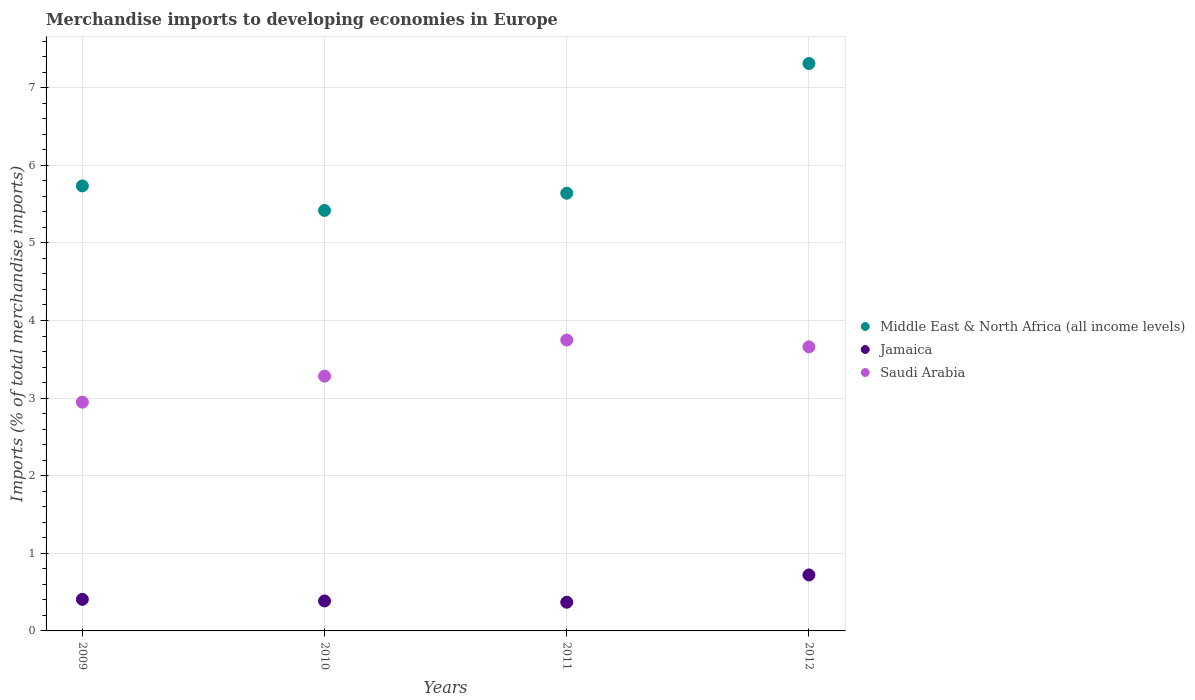How many different coloured dotlines are there?
Your answer should be compact. 3. What is the percentage total merchandise imports in Middle East & North Africa (all income levels) in 2011?
Your answer should be compact. 5.64. Across all years, what is the maximum percentage total merchandise imports in Middle East & North Africa (all income levels)?
Keep it short and to the point. 7.31. Across all years, what is the minimum percentage total merchandise imports in Middle East & North Africa (all income levels)?
Give a very brief answer. 5.42. What is the total percentage total merchandise imports in Saudi Arabia in the graph?
Give a very brief answer. 13.64. What is the difference between the percentage total merchandise imports in Middle East & North Africa (all income levels) in 2010 and that in 2012?
Ensure brevity in your answer.  -1.89. What is the difference between the percentage total merchandise imports in Middle East & North Africa (all income levels) in 2011 and the percentage total merchandise imports in Saudi Arabia in 2010?
Provide a succinct answer. 2.36. What is the average percentage total merchandise imports in Middle East & North Africa (all income levels) per year?
Your response must be concise. 6.03. In the year 2010, what is the difference between the percentage total merchandise imports in Saudi Arabia and percentage total merchandise imports in Jamaica?
Give a very brief answer. 2.9. In how many years, is the percentage total merchandise imports in Saudi Arabia greater than 6.2 %?
Give a very brief answer. 0. What is the ratio of the percentage total merchandise imports in Middle East & North Africa (all income levels) in 2011 to that in 2012?
Provide a succinct answer. 0.77. Is the percentage total merchandise imports in Saudi Arabia in 2010 less than that in 2011?
Ensure brevity in your answer.  Yes. Is the difference between the percentage total merchandise imports in Saudi Arabia in 2009 and 2011 greater than the difference between the percentage total merchandise imports in Jamaica in 2009 and 2011?
Your response must be concise. No. What is the difference between the highest and the second highest percentage total merchandise imports in Jamaica?
Make the answer very short. 0.31. What is the difference between the highest and the lowest percentage total merchandise imports in Jamaica?
Make the answer very short. 0.35. In how many years, is the percentage total merchandise imports in Middle East & North Africa (all income levels) greater than the average percentage total merchandise imports in Middle East & North Africa (all income levels) taken over all years?
Provide a short and direct response. 1. Does the percentage total merchandise imports in Middle East & North Africa (all income levels) monotonically increase over the years?
Your response must be concise. No. How many years are there in the graph?
Your answer should be very brief. 4. What is the difference between two consecutive major ticks on the Y-axis?
Give a very brief answer. 1. Are the values on the major ticks of Y-axis written in scientific E-notation?
Make the answer very short. No. Does the graph contain grids?
Offer a terse response. Yes. Where does the legend appear in the graph?
Give a very brief answer. Center right. How many legend labels are there?
Your answer should be compact. 3. How are the legend labels stacked?
Your answer should be very brief. Vertical. What is the title of the graph?
Your answer should be compact. Merchandise imports to developing economies in Europe. What is the label or title of the X-axis?
Provide a short and direct response. Years. What is the label or title of the Y-axis?
Keep it short and to the point. Imports (% of total merchandise imports). What is the Imports (% of total merchandise imports) in Middle East & North Africa (all income levels) in 2009?
Your answer should be very brief. 5.73. What is the Imports (% of total merchandise imports) of Jamaica in 2009?
Provide a short and direct response. 0.41. What is the Imports (% of total merchandise imports) in Saudi Arabia in 2009?
Provide a succinct answer. 2.95. What is the Imports (% of total merchandise imports) of Middle East & North Africa (all income levels) in 2010?
Your response must be concise. 5.42. What is the Imports (% of total merchandise imports) of Jamaica in 2010?
Make the answer very short. 0.39. What is the Imports (% of total merchandise imports) in Saudi Arabia in 2010?
Give a very brief answer. 3.28. What is the Imports (% of total merchandise imports) of Middle East & North Africa (all income levels) in 2011?
Provide a short and direct response. 5.64. What is the Imports (% of total merchandise imports) of Jamaica in 2011?
Ensure brevity in your answer.  0.37. What is the Imports (% of total merchandise imports) in Saudi Arabia in 2011?
Your answer should be very brief. 3.75. What is the Imports (% of total merchandise imports) of Middle East & North Africa (all income levels) in 2012?
Offer a terse response. 7.31. What is the Imports (% of total merchandise imports) of Jamaica in 2012?
Keep it short and to the point. 0.72. What is the Imports (% of total merchandise imports) of Saudi Arabia in 2012?
Ensure brevity in your answer.  3.66. Across all years, what is the maximum Imports (% of total merchandise imports) of Middle East & North Africa (all income levels)?
Your answer should be compact. 7.31. Across all years, what is the maximum Imports (% of total merchandise imports) of Jamaica?
Provide a short and direct response. 0.72. Across all years, what is the maximum Imports (% of total merchandise imports) in Saudi Arabia?
Offer a very short reply. 3.75. Across all years, what is the minimum Imports (% of total merchandise imports) of Middle East & North Africa (all income levels)?
Make the answer very short. 5.42. Across all years, what is the minimum Imports (% of total merchandise imports) of Jamaica?
Give a very brief answer. 0.37. Across all years, what is the minimum Imports (% of total merchandise imports) in Saudi Arabia?
Your response must be concise. 2.95. What is the total Imports (% of total merchandise imports) of Middle East & North Africa (all income levels) in the graph?
Provide a succinct answer. 24.1. What is the total Imports (% of total merchandise imports) of Jamaica in the graph?
Make the answer very short. 1.88. What is the total Imports (% of total merchandise imports) in Saudi Arabia in the graph?
Make the answer very short. 13.64. What is the difference between the Imports (% of total merchandise imports) of Middle East & North Africa (all income levels) in 2009 and that in 2010?
Offer a terse response. 0.32. What is the difference between the Imports (% of total merchandise imports) of Jamaica in 2009 and that in 2010?
Your answer should be compact. 0.02. What is the difference between the Imports (% of total merchandise imports) of Saudi Arabia in 2009 and that in 2010?
Keep it short and to the point. -0.33. What is the difference between the Imports (% of total merchandise imports) of Middle East & North Africa (all income levels) in 2009 and that in 2011?
Provide a succinct answer. 0.09. What is the difference between the Imports (% of total merchandise imports) of Jamaica in 2009 and that in 2011?
Make the answer very short. 0.04. What is the difference between the Imports (% of total merchandise imports) of Saudi Arabia in 2009 and that in 2011?
Ensure brevity in your answer.  -0.8. What is the difference between the Imports (% of total merchandise imports) in Middle East & North Africa (all income levels) in 2009 and that in 2012?
Keep it short and to the point. -1.58. What is the difference between the Imports (% of total merchandise imports) in Jamaica in 2009 and that in 2012?
Your answer should be very brief. -0.32. What is the difference between the Imports (% of total merchandise imports) in Saudi Arabia in 2009 and that in 2012?
Your response must be concise. -0.71. What is the difference between the Imports (% of total merchandise imports) in Middle East & North Africa (all income levels) in 2010 and that in 2011?
Give a very brief answer. -0.22. What is the difference between the Imports (% of total merchandise imports) in Jamaica in 2010 and that in 2011?
Your answer should be compact. 0.02. What is the difference between the Imports (% of total merchandise imports) of Saudi Arabia in 2010 and that in 2011?
Your answer should be very brief. -0.47. What is the difference between the Imports (% of total merchandise imports) in Middle East & North Africa (all income levels) in 2010 and that in 2012?
Your response must be concise. -1.89. What is the difference between the Imports (% of total merchandise imports) of Jamaica in 2010 and that in 2012?
Keep it short and to the point. -0.34. What is the difference between the Imports (% of total merchandise imports) of Saudi Arabia in 2010 and that in 2012?
Offer a very short reply. -0.38. What is the difference between the Imports (% of total merchandise imports) in Middle East & North Africa (all income levels) in 2011 and that in 2012?
Ensure brevity in your answer.  -1.67. What is the difference between the Imports (% of total merchandise imports) in Jamaica in 2011 and that in 2012?
Your answer should be compact. -0.35. What is the difference between the Imports (% of total merchandise imports) of Saudi Arabia in 2011 and that in 2012?
Offer a terse response. 0.09. What is the difference between the Imports (% of total merchandise imports) of Middle East & North Africa (all income levels) in 2009 and the Imports (% of total merchandise imports) of Jamaica in 2010?
Provide a short and direct response. 5.35. What is the difference between the Imports (% of total merchandise imports) in Middle East & North Africa (all income levels) in 2009 and the Imports (% of total merchandise imports) in Saudi Arabia in 2010?
Ensure brevity in your answer.  2.45. What is the difference between the Imports (% of total merchandise imports) of Jamaica in 2009 and the Imports (% of total merchandise imports) of Saudi Arabia in 2010?
Keep it short and to the point. -2.88. What is the difference between the Imports (% of total merchandise imports) of Middle East & North Africa (all income levels) in 2009 and the Imports (% of total merchandise imports) of Jamaica in 2011?
Give a very brief answer. 5.36. What is the difference between the Imports (% of total merchandise imports) in Middle East & North Africa (all income levels) in 2009 and the Imports (% of total merchandise imports) in Saudi Arabia in 2011?
Your response must be concise. 1.99. What is the difference between the Imports (% of total merchandise imports) in Jamaica in 2009 and the Imports (% of total merchandise imports) in Saudi Arabia in 2011?
Offer a very short reply. -3.34. What is the difference between the Imports (% of total merchandise imports) in Middle East & North Africa (all income levels) in 2009 and the Imports (% of total merchandise imports) in Jamaica in 2012?
Ensure brevity in your answer.  5.01. What is the difference between the Imports (% of total merchandise imports) in Middle East & North Africa (all income levels) in 2009 and the Imports (% of total merchandise imports) in Saudi Arabia in 2012?
Offer a very short reply. 2.07. What is the difference between the Imports (% of total merchandise imports) of Jamaica in 2009 and the Imports (% of total merchandise imports) of Saudi Arabia in 2012?
Provide a succinct answer. -3.25. What is the difference between the Imports (% of total merchandise imports) in Middle East & North Africa (all income levels) in 2010 and the Imports (% of total merchandise imports) in Jamaica in 2011?
Give a very brief answer. 5.05. What is the difference between the Imports (% of total merchandise imports) of Middle East & North Africa (all income levels) in 2010 and the Imports (% of total merchandise imports) of Saudi Arabia in 2011?
Ensure brevity in your answer.  1.67. What is the difference between the Imports (% of total merchandise imports) in Jamaica in 2010 and the Imports (% of total merchandise imports) in Saudi Arabia in 2011?
Provide a short and direct response. -3.36. What is the difference between the Imports (% of total merchandise imports) in Middle East & North Africa (all income levels) in 2010 and the Imports (% of total merchandise imports) in Jamaica in 2012?
Provide a succinct answer. 4.7. What is the difference between the Imports (% of total merchandise imports) of Middle East & North Africa (all income levels) in 2010 and the Imports (% of total merchandise imports) of Saudi Arabia in 2012?
Provide a short and direct response. 1.76. What is the difference between the Imports (% of total merchandise imports) of Jamaica in 2010 and the Imports (% of total merchandise imports) of Saudi Arabia in 2012?
Keep it short and to the point. -3.27. What is the difference between the Imports (% of total merchandise imports) of Middle East & North Africa (all income levels) in 2011 and the Imports (% of total merchandise imports) of Jamaica in 2012?
Keep it short and to the point. 4.92. What is the difference between the Imports (% of total merchandise imports) of Middle East & North Africa (all income levels) in 2011 and the Imports (% of total merchandise imports) of Saudi Arabia in 2012?
Your answer should be very brief. 1.98. What is the difference between the Imports (% of total merchandise imports) in Jamaica in 2011 and the Imports (% of total merchandise imports) in Saudi Arabia in 2012?
Make the answer very short. -3.29. What is the average Imports (% of total merchandise imports) in Middle East & North Africa (all income levels) per year?
Provide a short and direct response. 6.03. What is the average Imports (% of total merchandise imports) in Jamaica per year?
Your answer should be very brief. 0.47. What is the average Imports (% of total merchandise imports) in Saudi Arabia per year?
Offer a terse response. 3.41. In the year 2009, what is the difference between the Imports (% of total merchandise imports) in Middle East & North Africa (all income levels) and Imports (% of total merchandise imports) in Jamaica?
Give a very brief answer. 5.33. In the year 2009, what is the difference between the Imports (% of total merchandise imports) of Middle East & North Africa (all income levels) and Imports (% of total merchandise imports) of Saudi Arabia?
Your response must be concise. 2.79. In the year 2009, what is the difference between the Imports (% of total merchandise imports) of Jamaica and Imports (% of total merchandise imports) of Saudi Arabia?
Ensure brevity in your answer.  -2.54. In the year 2010, what is the difference between the Imports (% of total merchandise imports) of Middle East & North Africa (all income levels) and Imports (% of total merchandise imports) of Jamaica?
Offer a terse response. 5.03. In the year 2010, what is the difference between the Imports (% of total merchandise imports) in Middle East & North Africa (all income levels) and Imports (% of total merchandise imports) in Saudi Arabia?
Your response must be concise. 2.14. In the year 2010, what is the difference between the Imports (% of total merchandise imports) in Jamaica and Imports (% of total merchandise imports) in Saudi Arabia?
Offer a very short reply. -2.9. In the year 2011, what is the difference between the Imports (% of total merchandise imports) of Middle East & North Africa (all income levels) and Imports (% of total merchandise imports) of Jamaica?
Your response must be concise. 5.27. In the year 2011, what is the difference between the Imports (% of total merchandise imports) in Middle East & North Africa (all income levels) and Imports (% of total merchandise imports) in Saudi Arabia?
Make the answer very short. 1.89. In the year 2011, what is the difference between the Imports (% of total merchandise imports) of Jamaica and Imports (% of total merchandise imports) of Saudi Arabia?
Your response must be concise. -3.38. In the year 2012, what is the difference between the Imports (% of total merchandise imports) in Middle East & North Africa (all income levels) and Imports (% of total merchandise imports) in Jamaica?
Your answer should be very brief. 6.59. In the year 2012, what is the difference between the Imports (% of total merchandise imports) of Middle East & North Africa (all income levels) and Imports (% of total merchandise imports) of Saudi Arabia?
Give a very brief answer. 3.65. In the year 2012, what is the difference between the Imports (% of total merchandise imports) in Jamaica and Imports (% of total merchandise imports) in Saudi Arabia?
Your answer should be very brief. -2.94. What is the ratio of the Imports (% of total merchandise imports) of Middle East & North Africa (all income levels) in 2009 to that in 2010?
Your answer should be compact. 1.06. What is the ratio of the Imports (% of total merchandise imports) of Jamaica in 2009 to that in 2010?
Your answer should be very brief. 1.05. What is the ratio of the Imports (% of total merchandise imports) in Saudi Arabia in 2009 to that in 2010?
Your answer should be compact. 0.9. What is the ratio of the Imports (% of total merchandise imports) in Middle East & North Africa (all income levels) in 2009 to that in 2011?
Keep it short and to the point. 1.02. What is the ratio of the Imports (% of total merchandise imports) of Jamaica in 2009 to that in 2011?
Provide a short and direct response. 1.1. What is the ratio of the Imports (% of total merchandise imports) in Saudi Arabia in 2009 to that in 2011?
Give a very brief answer. 0.79. What is the ratio of the Imports (% of total merchandise imports) of Middle East & North Africa (all income levels) in 2009 to that in 2012?
Ensure brevity in your answer.  0.78. What is the ratio of the Imports (% of total merchandise imports) of Jamaica in 2009 to that in 2012?
Offer a very short reply. 0.56. What is the ratio of the Imports (% of total merchandise imports) in Saudi Arabia in 2009 to that in 2012?
Your response must be concise. 0.81. What is the ratio of the Imports (% of total merchandise imports) in Middle East & North Africa (all income levels) in 2010 to that in 2011?
Offer a very short reply. 0.96. What is the ratio of the Imports (% of total merchandise imports) in Jamaica in 2010 to that in 2011?
Provide a short and direct response. 1.04. What is the ratio of the Imports (% of total merchandise imports) in Saudi Arabia in 2010 to that in 2011?
Give a very brief answer. 0.88. What is the ratio of the Imports (% of total merchandise imports) of Middle East & North Africa (all income levels) in 2010 to that in 2012?
Provide a short and direct response. 0.74. What is the ratio of the Imports (% of total merchandise imports) in Jamaica in 2010 to that in 2012?
Give a very brief answer. 0.54. What is the ratio of the Imports (% of total merchandise imports) in Saudi Arabia in 2010 to that in 2012?
Keep it short and to the point. 0.9. What is the ratio of the Imports (% of total merchandise imports) in Middle East & North Africa (all income levels) in 2011 to that in 2012?
Your response must be concise. 0.77. What is the ratio of the Imports (% of total merchandise imports) in Jamaica in 2011 to that in 2012?
Your answer should be compact. 0.51. What is the difference between the highest and the second highest Imports (% of total merchandise imports) in Middle East & North Africa (all income levels)?
Ensure brevity in your answer.  1.58. What is the difference between the highest and the second highest Imports (% of total merchandise imports) in Jamaica?
Offer a very short reply. 0.32. What is the difference between the highest and the second highest Imports (% of total merchandise imports) of Saudi Arabia?
Give a very brief answer. 0.09. What is the difference between the highest and the lowest Imports (% of total merchandise imports) in Middle East & North Africa (all income levels)?
Provide a succinct answer. 1.89. What is the difference between the highest and the lowest Imports (% of total merchandise imports) in Jamaica?
Offer a terse response. 0.35. What is the difference between the highest and the lowest Imports (% of total merchandise imports) in Saudi Arabia?
Give a very brief answer. 0.8. 